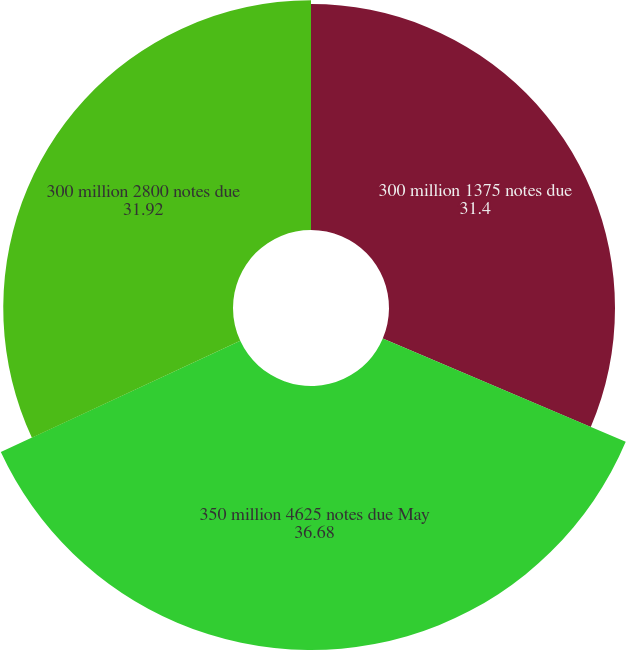Convert chart to OTSL. <chart><loc_0><loc_0><loc_500><loc_500><pie_chart><fcel>300 million 1375 notes due<fcel>350 million 4625 notes due May<fcel>300 million 2800 notes due<nl><fcel>31.4%<fcel>36.68%<fcel>31.92%<nl></chart> 